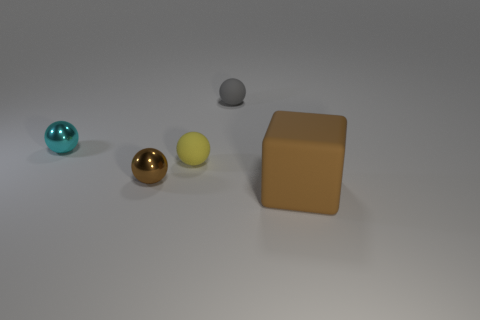Subtract all tiny cyan metallic balls. How many balls are left? 3 Subtract all gray balls. How many balls are left? 3 Add 5 tiny brown metal objects. How many objects exist? 10 Subtract all spheres. How many objects are left? 1 Subtract 0 brown cylinders. How many objects are left? 5 Subtract all purple spheres. Subtract all red cubes. How many spheres are left? 4 Subtract all blue cylinders. How many yellow balls are left? 1 Subtract all blocks. Subtract all tiny cyan metal objects. How many objects are left? 3 Add 4 small balls. How many small balls are left? 8 Add 5 small yellow metallic blocks. How many small yellow metallic blocks exist? 5 